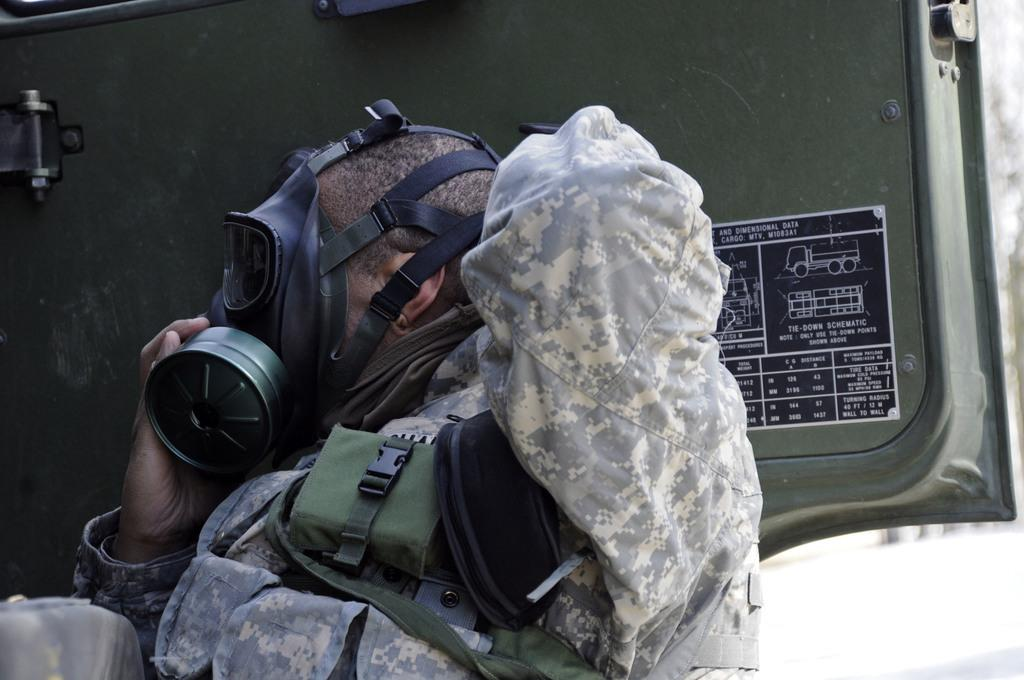What is the main subject of the image? The main subject of the image is a man. Can you describe the man's attire? The man is wearing a uniform and a face mask. What can be seen on the vehicle door in the image? There is a poster on the vehicle door. What is depicted on the poster? The poster contains images and text. How many lizards are crawling on the man's uniform in the image? There are no lizards present in the image. Can you see any dogs in the image? There are no dogs present in the image. 